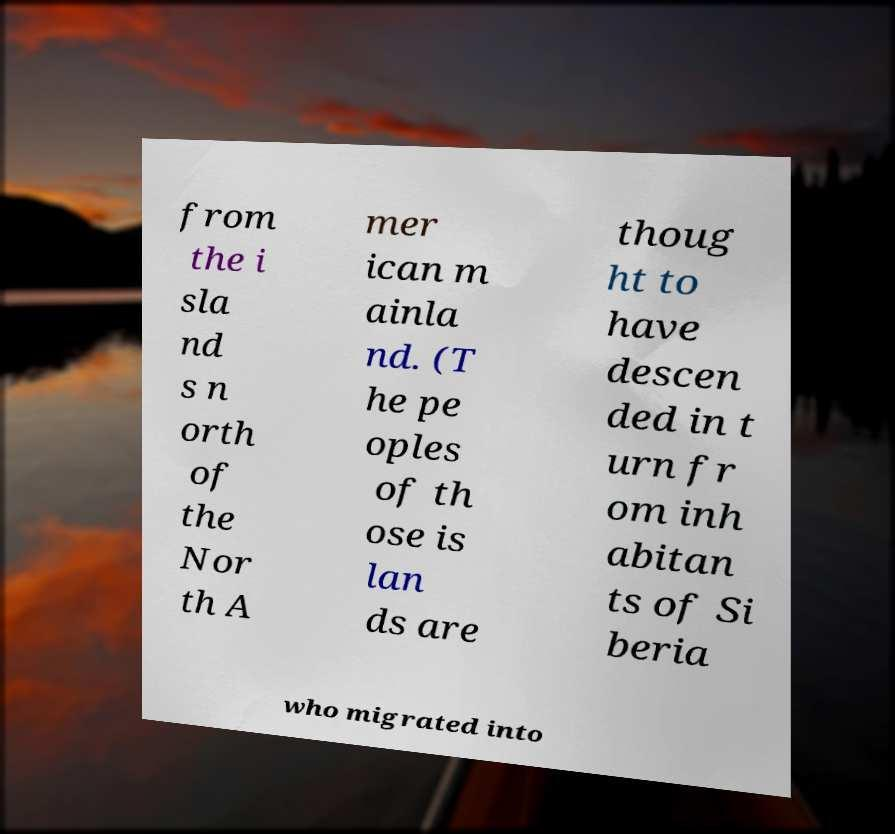For documentation purposes, I need the text within this image transcribed. Could you provide that? from the i sla nd s n orth of the Nor th A mer ican m ainla nd. (T he pe oples of th ose is lan ds are thoug ht to have descen ded in t urn fr om inh abitan ts of Si beria who migrated into 